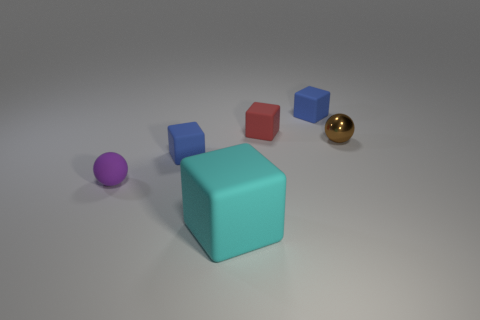How many purple objects are either balls or tiny matte spheres?
Your response must be concise. 1. There is a tiny ball that is made of the same material as the large cyan object; what color is it?
Keep it short and to the point. Purple. Is there anything else that has the same size as the metallic object?
Make the answer very short. Yes. How many tiny objects are brown balls or yellow matte balls?
Offer a very short reply. 1. Is the number of red shiny cylinders less than the number of big cyan blocks?
Make the answer very short. Yes. The other shiny thing that is the same shape as the purple object is what color?
Offer a terse response. Brown. Is there anything else that has the same shape as the small red matte object?
Offer a terse response. Yes. Are there more small blocks than metallic balls?
Provide a succinct answer. Yes. How many other objects are there of the same material as the big cyan block?
Ensure brevity in your answer.  4. The object in front of the small ball in front of the blue cube that is on the left side of the cyan block is what shape?
Offer a very short reply. Cube. 